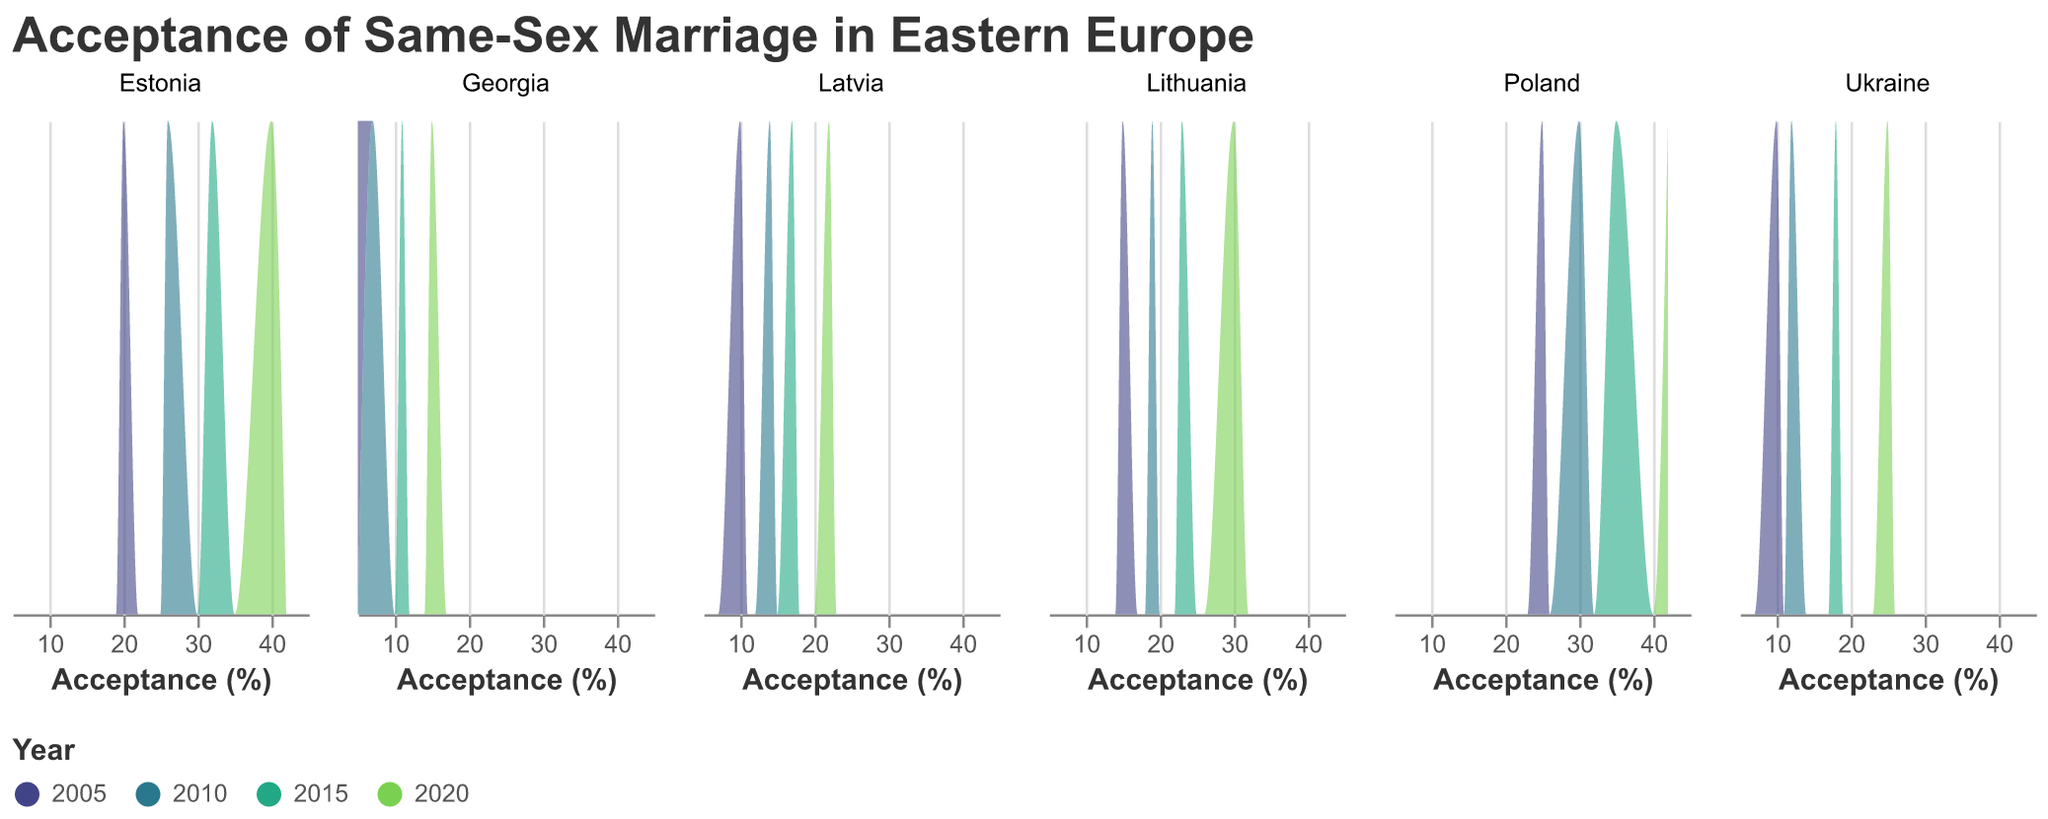What is the title of the plot? The title is prominently displayed at the top of the plot and reads "Acceptance of Same-Sex Marriage in Eastern Europe".
Answer: Acceptance of Same-Sex Marriage in Eastern Europe How many countries are represented in the plot? Each subplot represents one country, and the figure includes subplots for Georgia, Ukraine, Estonia, Lithuania, Latvia, and Poland.
Answer: 6 Which country shows the highest acceptance percentage in 2020? By looking at the highest value of the Acceptance Percentage axis in the 2020 section of each subplot, Poland shows the highest acceptance percentage of 42%.
Answer: Poland How has the acceptance percentage in Georgia changed from 2005 to 2020? By tracing the progression through the years in the Georgia subplot, we see that acceptance increased from 5% in 2005 to 15% in 2020, showing a gradual increase over the years.
Answer: It increased from 5% to 15% Which year is represented with the darkest color in the plot? According to the color legend at the bottom, the darkest color corresponds to the year 2020.
Answer: 2020 Compare the acceptance percentage trends over the years for Ukraine and Lithuania. Observing the subplots for Ukraine and Lithuania, both countries show an increasing trend over the years. However, Ukraine starts at a lower level (10% in 2005) and rises to 25% in 2020, whereas Lithuania begins at 15% and increases to 30% in 2020. In both cases, the increase is consistent but Lithuania has higher values overall.
Answer: Both show increasing trends, but Lithuania has higher values overall What is the acceptance percentage in Latvia for 2010 and 2015? Looking at Latvia's subplot, the acceptance percentage for 2010 is 14% and for 2015 is 17%.
Answer: 14% and 17% Is there any country where the acceptance percentage did not increase in any of the years shown? Checking each subplot, all countries show an increasing trend in acceptance percentage from 2005 to 2020.
Answer: No Among Estonia, Lithuania, and Latvia, which country had the highest acceptance in 2005? Observing the acceptance percentages for 2005 in each subplot: 
- Estonia: 20% 
- Lithuania: 15% 
- Latvia: 10% 
Estonia has the highest acceptance percentage in 2005.
Answer: Estonia 